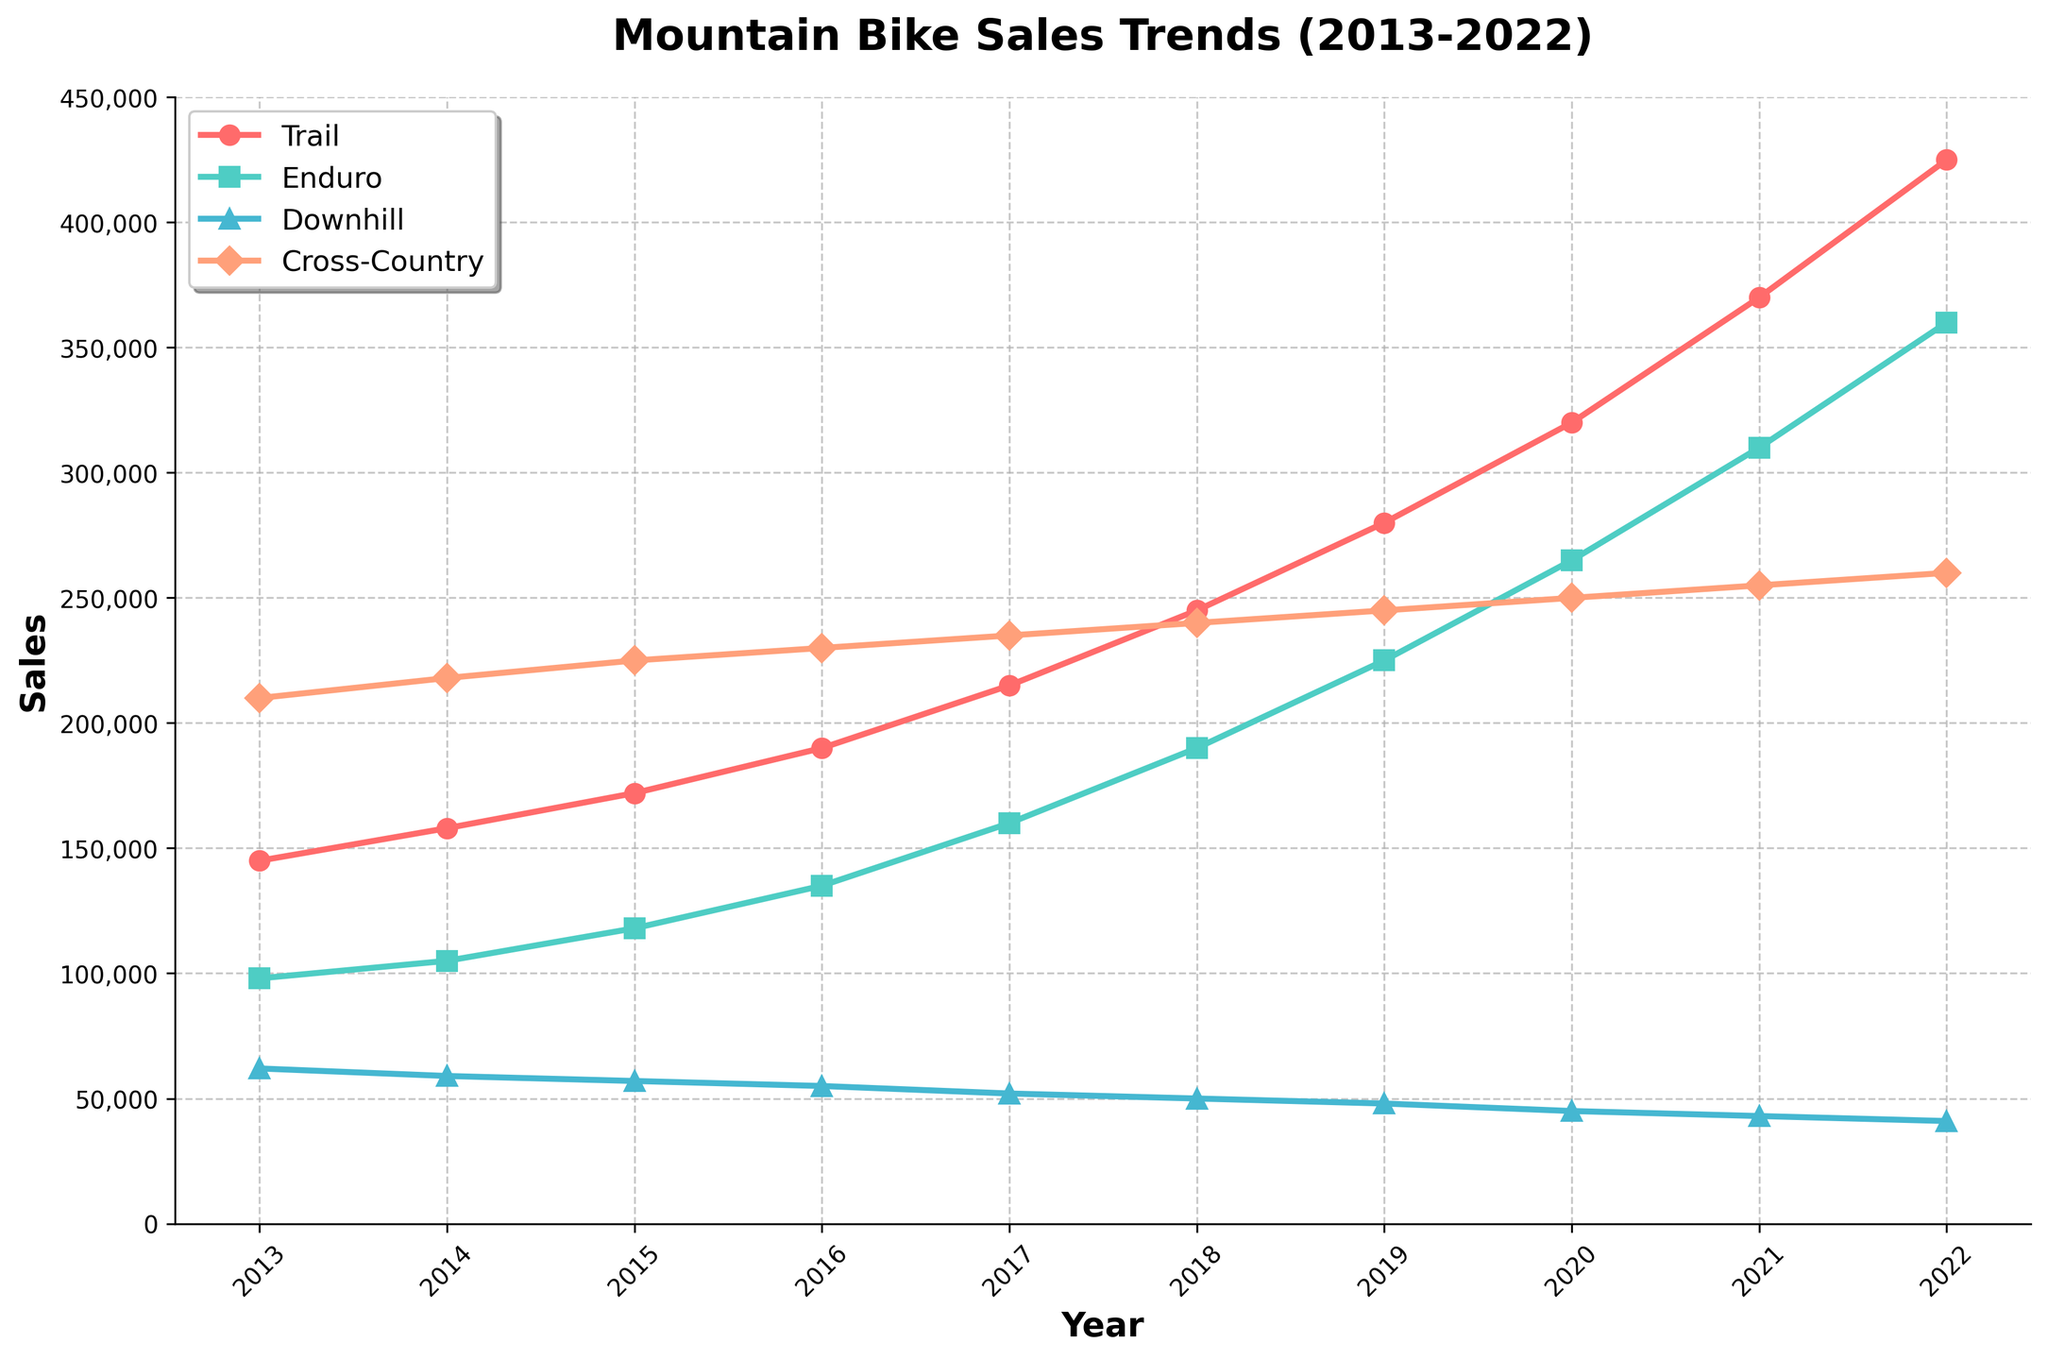What is the highest sales number for Trail bikes in the decade? Look at the Trail bikes sales line (represented with a distinct color and marker), find the highest point on this line, which corresponds to the highest sales number.
Answer: 425,000 Which bike type had the least sales in 2022? Observe the sales values for each bike type at the year 2022 and identify the one with the smallest value.
Answer: Downhill How much did sales for Enduro bikes increase from 2016 to 2020? Find the sales numbers for Enduro bikes in 2016 and 2020, subtract the 2016 value from the 2020 value to get the sales increase. Specifically, 265,000 - 135,000.
Answer: 130,000 Which year did Cross-Country sales have the smallest growth compared to the previous year? Calculate the year-over-year differences for Cross-Country sales and determine which year had the smallest increase. The smallest increment, compared to prior years, can be observed between 2016 and 2017 (235,000 - 230,000 = 5,000).
Answer: 2017 Between which two consecutive years did Trail bikes see the greatest sales increase? Compute the difference in Trail bike sales between each pair of consecutive years and find the pair with the greatest difference. The largest difference can be observed between 2021 and 2022 (425,000 - 370,000).
Answer: 2021-2022 Which bike type consistently showed an increasing sales trend every year from 2013 to 2022? Examine the sales trends for each bike type, observing whether the sales figures for each year are greater than the previous year's figures. Cross-Country bikes consistently have increasing sales over the period.
Answer: Cross-Country What is the approximate total sales for all bike types in 2020? Find the sales numbers for each bike type in 2020 and sum them up (320,000 + 265,000 + 45,000 + 250,000).
Answer: 880,000 For which type of bike did the sales trend appear to be relatively flat or declining? Analyze the trends for each bike type, paying attention to the overall directions of their lines. Downhill bikes show a generally declining trend.
Answer: Downhill Compare the sales of Cross-Country bikes in 2013 and Enduro bikes in 2022. Which is higher and by how much? Find the sales numbers for Cross-Country bikes in 2013 and Enduro bikes in 2022, then subtract the former from the latter to determine which is higher and by how much (360,000 - 210,000).
Answer: Enduro by 150,000 Which year observed the same sales number for Downhill bikes as in 2021? Identify the sales value of Downhill bikes for 2021 (43,000) and check other years in the series to see if any year matches this value.
Answer: None 